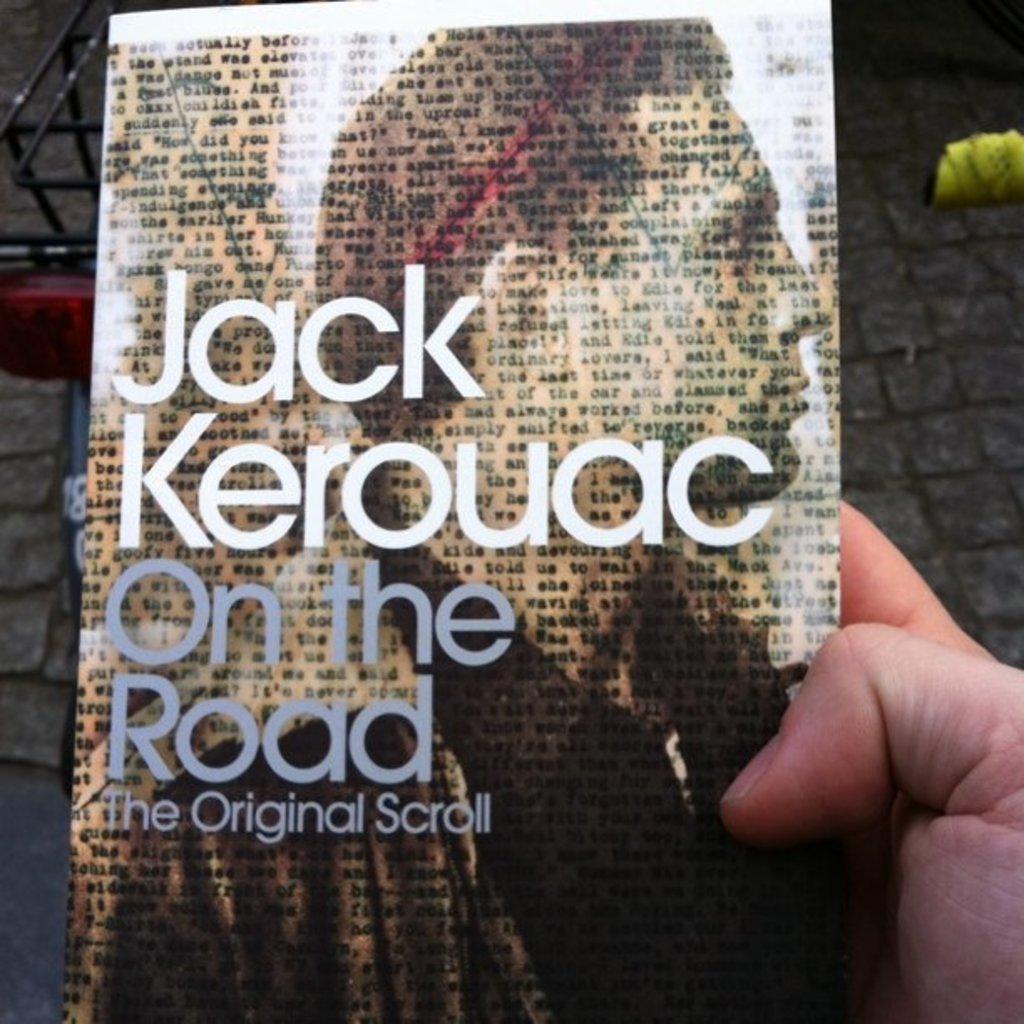How would you summarize this image in a sentence or two? In this image there is a book in the middle. On the right side there is a hand which is holding the book. On the book cover there is a man. 